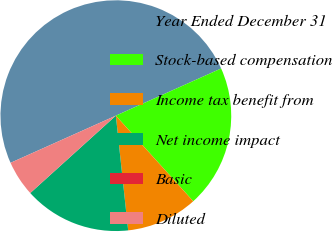Convert chart to OTSL. <chart><loc_0><loc_0><loc_500><loc_500><pie_chart><fcel>Year Ended December 31<fcel>Stock-based compensation<fcel>Income tax benefit from<fcel>Net income impact<fcel>Basic<fcel>Diluted<nl><fcel>50.0%<fcel>20.0%<fcel>10.0%<fcel>15.0%<fcel>0.0%<fcel>5.0%<nl></chart> 